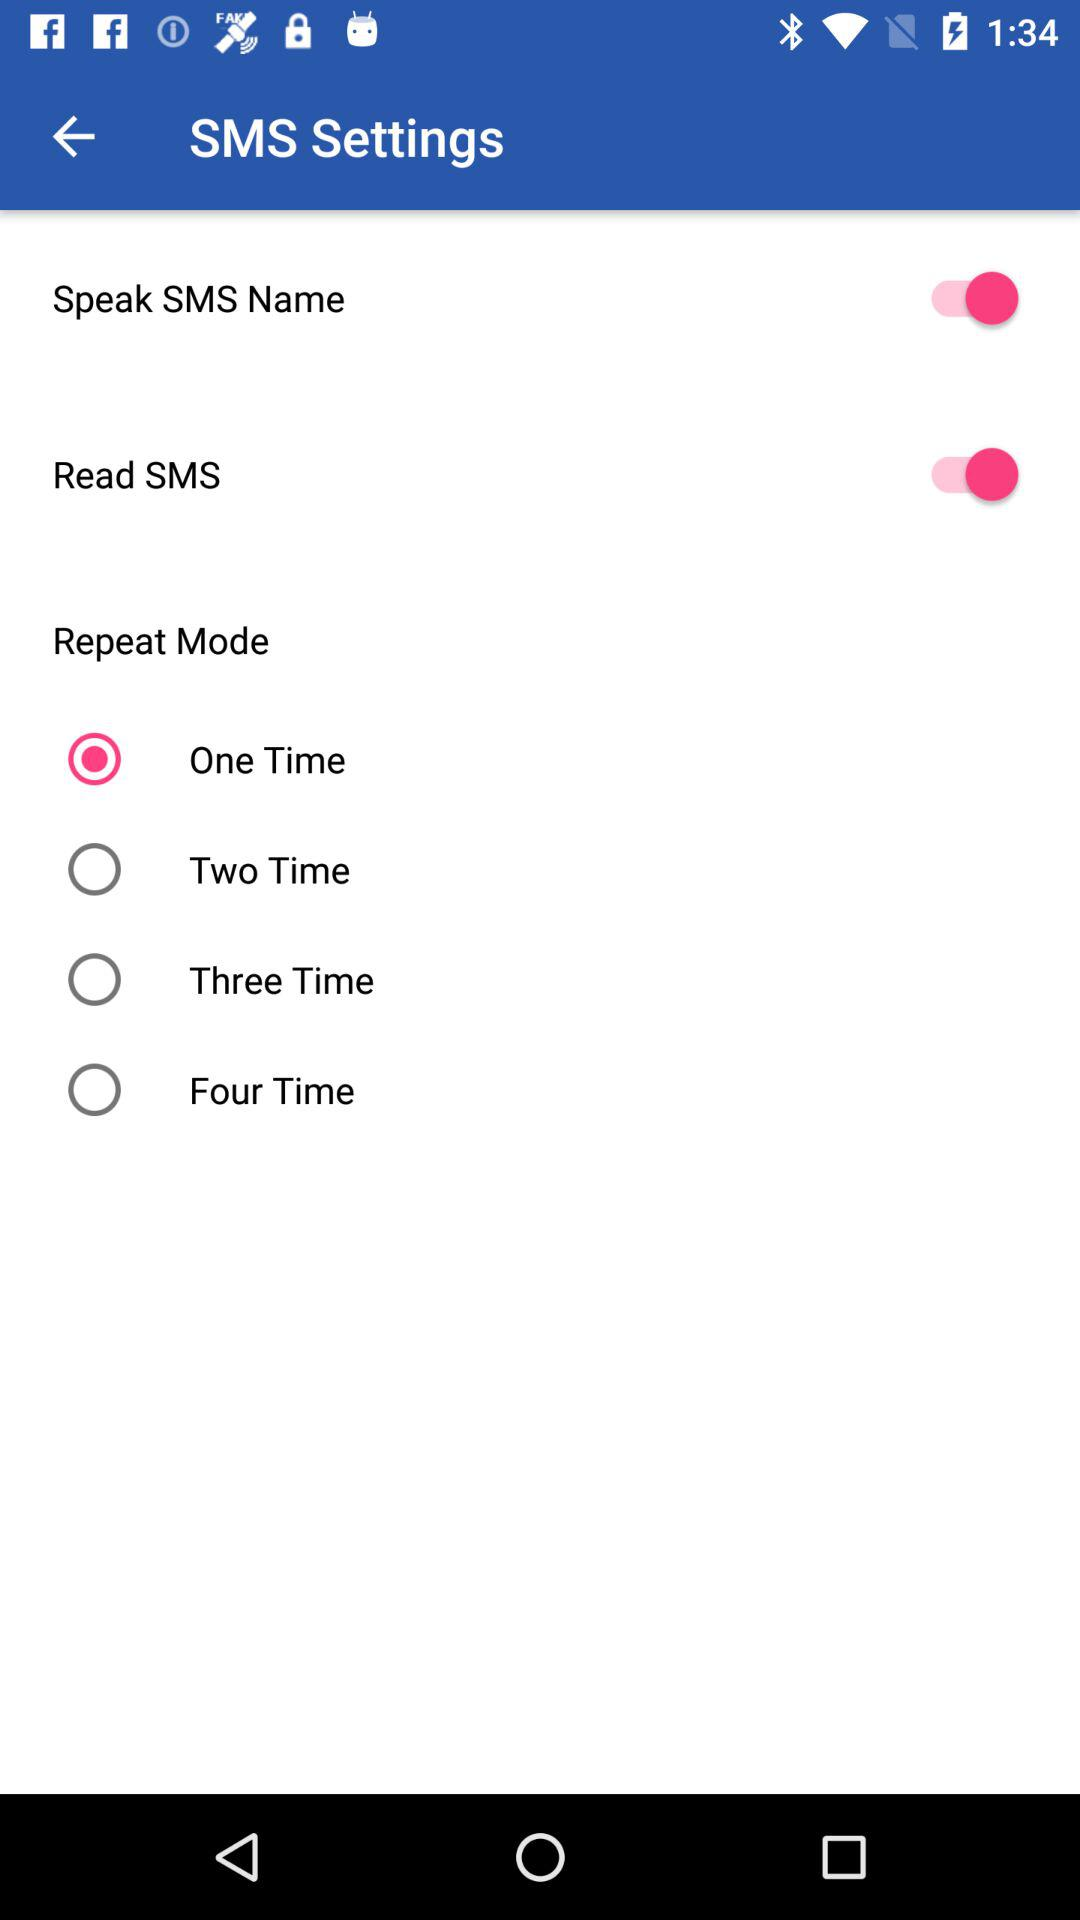What is the status of the "Read SMS"? The status is "on". 